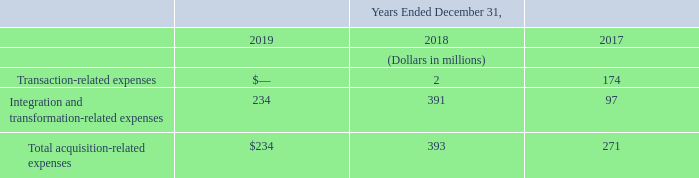Acquisition-Related Expenses
We have incurred acquisition-related expenses related to our acquisition of Level 3. The table below summarizes our acquisition-related expenses, which consist of integration and transformation-related expenses, including severance and retention compensation expenses, and transaction-related expenses:
At December 31, 2019, we had incurred cumulative acquisition-related expenses of $950 million for Level 3. The total amounts of these expenses are included in our selling, general and administrative expenses.
Level 3 incurred transaction-related expenses of $47 million on the date of acquisition. This amount is not included in our results of operations.
What was the amount of cumulative acquisition-related expenses incurred for Level 3 in 2019? $950 million. What was the amount of transaction-related expenses incurred for Level 3 on the date of acquisition? $47 million. What expenses are included under the acquisition-related expenses? Integration and transformation-related expenses, severance and retention compensation expenses, transaction-related expenses. Which year incurred the lowest amount of total acquisition-related expenses? 234<271<393
Answer: 2019. What is the change in the total acquisition-related expense in 2019 from 2018?
Answer scale should be: million. 234-393
Answer: -159. What is the percentage change in the total acquisition-related expense in 2019 from 2018?
Answer scale should be: percent. (234-393)/393
Answer: -40.46. 